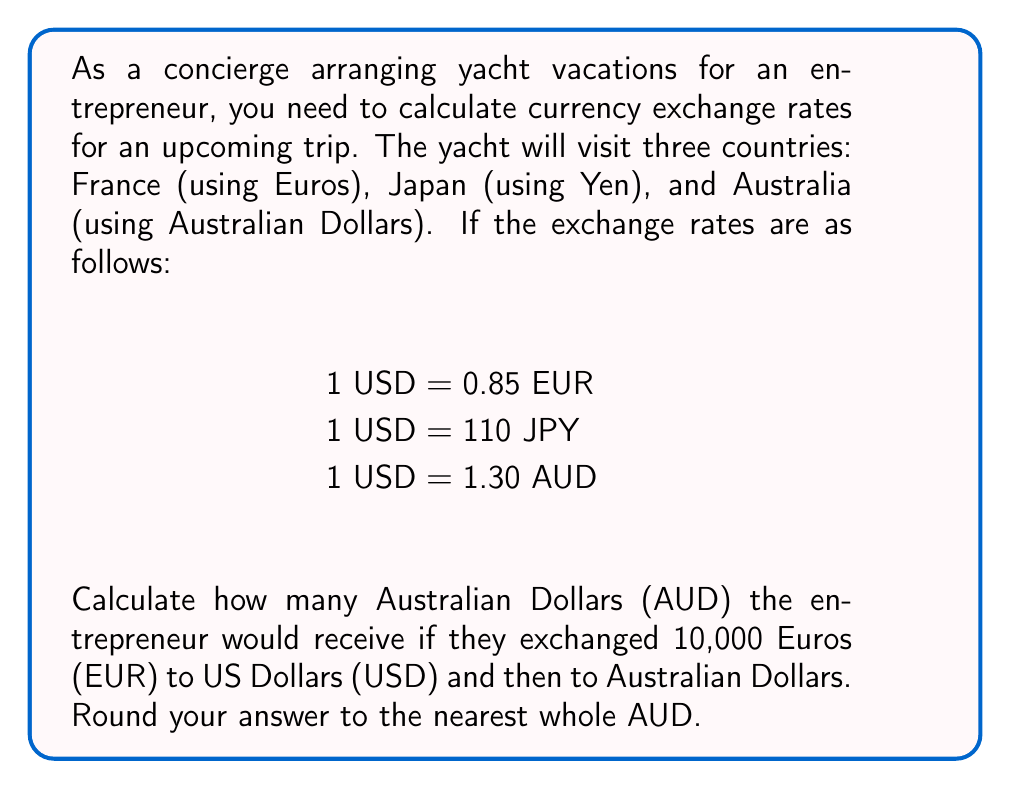Can you solve this math problem? To solve this problem, we'll follow these steps:

1) First, convert EUR to USD:
   Let $x$ be the amount in USD.
   $$10000 \text{ EUR} = x \text{ USD}$$
   $$\frac{10000}{0.85} = x$$
   $$x = 11764.71 \text{ USD}$$

2) Now, convert USD to AUD:
   $$11764.71 \text{ USD} = y \text{ AUD}$$
   $$y = 11764.71 \times 1.30$$
   $$y = 15294.12 \text{ AUD}$$

3) Rounding to the nearest whole AUD:
   $$15294.12 \text{ AUD} \approx 15294 \text{ AUD}$$

Therefore, if the entrepreneur exchanged 10,000 EUR to USD and then to AUD, they would receive approximately 15,294 AUD.
Answer: 15,294 AUD 